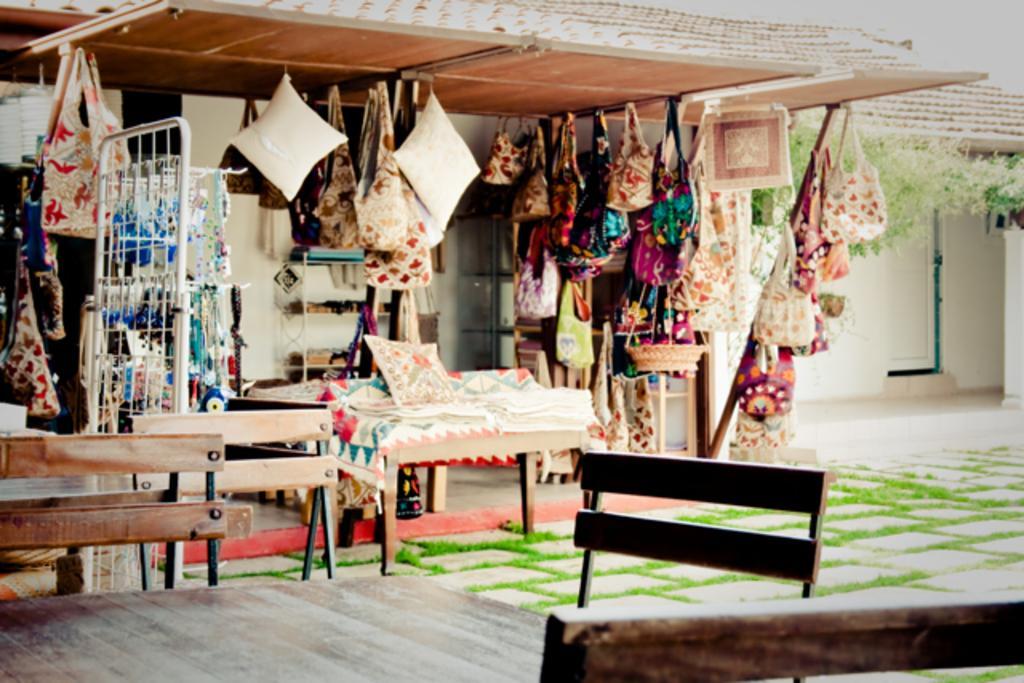Can you describe this image briefly? In this picture we can see chairs, tables and some grass on the ground. We can see handbags, pillows and a few objects in the racks. There are other objects visible in the shed shop. We can see planets and a few things in the background. 